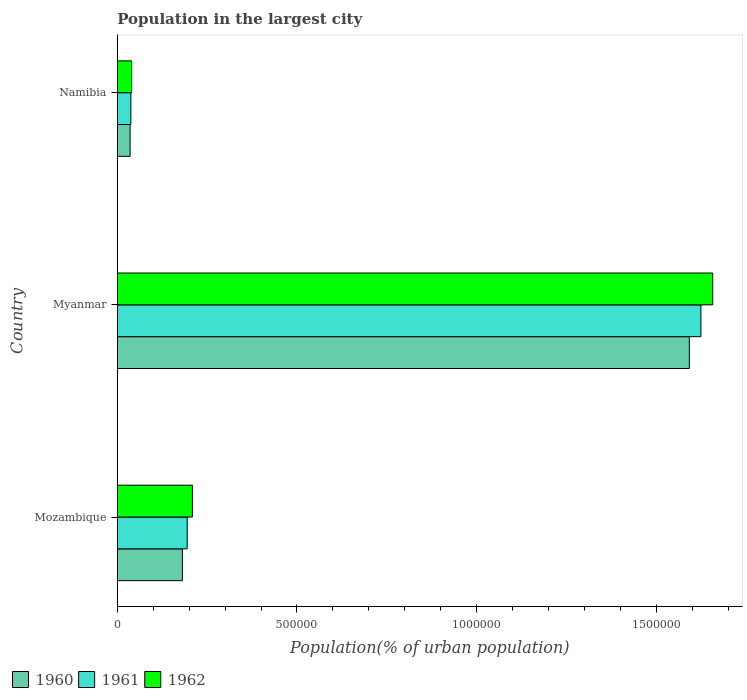Are the number of bars per tick equal to the number of legend labels?
Provide a succinct answer. Yes. Are the number of bars on each tick of the Y-axis equal?
Give a very brief answer. Yes. How many bars are there on the 1st tick from the top?
Offer a very short reply. 3. What is the label of the 1st group of bars from the top?
Your response must be concise. Namibia. In how many cases, is the number of bars for a given country not equal to the number of legend labels?
Make the answer very short. 0. What is the population in the largest city in 1960 in Mozambique?
Provide a short and direct response. 1.81e+05. Across all countries, what is the maximum population in the largest city in 1960?
Your answer should be compact. 1.59e+06. Across all countries, what is the minimum population in the largest city in 1962?
Your response must be concise. 3.99e+04. In which country was the population in the largest city in 1962 maximum?
Your response must be concise. Myanmar. In which country was the population in the largest city in 1962 minimum?
Your answer should be compact. Namibia. What is the total population in the largest city in 1960 in the graph?
Provide a short and direct response. 1.81e+06. What is the difference between the population in the largest city in 1961 in Mozambique and that in Namibia?
Offer a terse response. 1.57e+05. What is the difference between the population in the largest city in 1962 in Namibia and the population in the largest city in 1960 in Mozambique?
Offer a terse response. -1.41e+05. What is the average population in the largest city in 1961 per country?
Your response must be concise. 6.19e+05. What is the difference between the population in the largest city in 1960 and population in the largest city in 1961 in Myanmar?
Your response must be concise. -3.22e+04. What is the ratio of the population in the largest city in 1962 in Mozambique to that in Myanmar?
Provide a succinct answer. 0.13. What is the difference between the highest and the second highest population in the largest city in 1960?
Give a very brief answer. 1.41e+06. What is the difference between the highest and the lowest population in the largest city in 1960?
Provide a short and direct response. 1.56e+06. Is the sum of the population in the largest city in 1961 in Myanmar and Namibia greater than the maximum population in the largest city in 1962 across all countries?
Offer a terse response. Yes. What does the 1st bar from the top in Myanmar represents?
Provide a succinct answer. 1962. Is it the case that in every country, the sum of the population in the largest city in 1960 and population in the largest city in 1961 is greater than the population in the largest city in 1962?
Your answer should be very brief. Yes. Are all the bars in the graph horizontal?
Provide a succinct answer. Yes. What is the difference between two consecutive major ticks on the X-axis?
Make the answer very short. 5.00e+05. Does the graph contain any zero values?
Your answer should be very brief. No. Does the graph contain grids?
Provide a short and direct response. No. Where does the legend appear in the graph?
Offer a very short reply. Bottom left. What is the title of the graph?
Your response must be concise. Population in the largest city. Does "1995" appear as one of the legend labels in the graph?
Offer a very short reply. No. What is the label or title of the X-axis?
Ensure brevity in your answer.  Population(% of urban population). What is the label or title of the Y-axis?
Keep it short and to the point. Country. What is the Population(% of urban population) in 1960 in Mozambique?
Make the answer very short. 1.81e+05. What is the Population(% of urban population) in 1961 in Mozambique?
Your response must be concise. 1.95e+05. What is the Population(% of urban population) of 1962 in Mozambique?
Keep it short and to the point. 2.09e+05. What is the Population(% of urban population) of 1960 in Myanmar?
Offer a terse response. 1.59e+06. What is the Population(% of urban population) of 1961 in Myanmar?
Your answer should be very brief. 1.62e+06. What is the Population(% of urban population) in 1962 in Myanmar?
Offer a terse response. 1.66e+06. What is the Population(% of urban population) in 1960 in Namibia?
Your answer should be compact. 3.57e+04. What is the Population(% of urban population) of 1961 in Namibia?
Offer a very short reply. 3.77e+04. What is the Population(% of urban population) of 1962 in Namibia?
Make the answer very short. 3.99e+04. Across all countries, what is the maximum Population(% of urban population) in 1960?
Offer a very short reply. 1.59e+06. Across all countries, what is the maximum Population(% of urban population) in 1961?
Keep it short and to the point. 1.62e+06. Across all countries, what is the maximum Population(% of urban population) in 1962?
Your response must be concise. 1.66e+06. Across all countries, what is the minimum Population(% of urban population) of 1960?
Offer a very short reply. 3.57e+04. Across all countries, what is the minimum Population(% of urban population) in 1961?
Your answer should be compact. 3.77e+04. Across all countries, what is the minimum Population(% of urban population) in 1962?
Keep it short and to the point. 3.99e+04. What is the total Population(% of urban population) of 1960 in the graph?
Keep it short and to the point. 1.81e+06. What is the total Population(% of urban population) of 1961 in the graph?
Provide a succinct answer. 1.86e+06. What is the total Population(% of urban population) in 1962 in the graph?
Keep it short and to the point. 1.91e+06. What is the difference between the Population(% of urban population) in 1960 in Mozambique and that in Myanmar?
Provide a short and direct response. -1.41e+06. What is the difference between the Population(% of urban population) in 1961 in Mozambique and that in Myanmar?
Offer a terse response. -1.43e+06. What is the difference between the Population(% of urban population) in 1962 in Mozambique and that in Myanmar?
Make the answer very short. -1.45e+06. What is the difference between the Population(% of urban population) in 1960 in Mozambique and that in Namibia?
Make the answer very short. 1.46e+05. What is the difference between the Population(% of urban population) in 1961 in Mozambique and that in Namibia?
Provide a succinct answer. 1.57e+05. What is the difference between the Population(% of urban population) in 1962 in Mozambique and that in Namibia?
Keep it short and to the point. 1.69e+05. What is the difference between the Population(% of urban population) in 1960 in Myanmar and that in Namibia?
Your answer should be very brief. 1.56e+06. What is the difference between the Population(% of urban population) in 1961 in Myanmar and that in Namibia?
Give a very brief answer. 1.59e+06. What is the difference between the Population(% of urban population) of 1962 in Myanmar and that in Namibia?
Your response must be concise. 1.62e+06. What is the difference between the Population(% of urban population) of 1960 in Mozambique and the Population(% of urban population) of 1961 in Myanmar?
Provide a succinct answer. -1.44e+06. What is the difference between the Population(% of urban population) in 1960 in Mozambique and the Population(% of urban population) in 1962 in Myanmar?
Give a very brief answer. -1.48e+06. What is the difference between the Population(% of urban population) in 1961 in Mozambique and the Population(% of urban population) in 1962 in Myanmar?
Keep it short and to the point. -1.46e+06. What is the difference between the Population(% of urban population) in 1960 in Mozambique and the Population(% of urban population) in 1961 in Namibia?
Offer a terse response. 1.43e+05. What is the difference between the Population(% of urban population) in 1960 in Mozambique and the Population(% of urban population) in 1962 in Namibia?
Keep it short and to the point. 1.41e+05. What is the difference between the Population(% of urban population) of 1961 in Mozambique and the Population(% of urban population) of 1962 in Namibia?
Ensure brevity in your answer.  1.55e+05. What is the difference between the Population(% of urban population) in 1960 in Myanmar and the Population(% of urban population) in 1961 in Namibia?
Give a very brief answer. 1.55e+06. What is the difference between the Population(% of urban population) in 1960 in Myanmar and the Population(% of urban population) in 1962 in Namibia?
Your answer should be very brief. 1.55e+06. What is the difference between the Population(% of urban population) of 1961 in Myanmar and the Population(% of urban population) of 1962 in Namibia?
Your answer should be compact. 1.58e+06. What is the average Population(% of urban population) of 1960 per country?
Ensure brevity in your answer.  6.03e+05. What is the average Population(% of urban population) in 1961 per country?
Your response must be concise. 6.19e+05. What is the average Population(% of urban population) in 1962 per country?
Ensure brevity in your answer.  6.35e+05. What is the difference between the Population(% of urban population) in 1960 and Population(% of urban population) in 1961 in Mozambique?
Keep it short and to the point. -1.33e+04. What is the difference between the Population(% of urban population) in 1960 and Population(% of urban population) in 1962 in Mozambique?
Your answer should be very brief. -2.78e+04. What is the difference between the Population(% of urban population) of 1961 and Population(% of urban population) of 1962 in Mozambique?
Offer a very short reply. -1.45e+04. What is the difference between the Population(% of urban population) in 1960 and Population(% of urban population) in 1961 in Myanmar?
Keep it short and to the point. -3.22e+04. What is the difference between the Population(% of urban population) in 1960 and Population(% of urban population) in 1962 in Myanmar?
Provide a short and direct response. -6.52e+04. What is the difference between the Population(% of urban population) in 1961 and Population(% of urban population) in 1962 in Myanmar?
Offer a very short reply. -3.29e+04. What is the difference between the Population(% of urban population) of 1960 and Population(% of urban population) of 1961 in Namibia?
Offer a terse response. -2070. What is the difference between the Population(% of urban population) of 1960 and Population(% of urban population) of 1962 in Namibia?
Provide a short and direct response. -4228. What is the difference between the Population(% of urban population) in 1961 and Population(% of urban population) in 1962 in Namibia?
Your response must be concise. -2158. What is the ratio of the Population(% of urban population) in 1960 in Mozambique to that in Myanmar?
Give a very brief answer. 0.11. What is the ratio of the Population(% of urban population) of 1961 in Mozambique to that in Myanmar?
Your answer should be compact. 0.12. What is the ratio of the Population(% of urban population) of 1962 in Mozambique to that in Myanmar?
Offer a very short reply. 0.13. What is the ratio of the Population(% of urban population) of 1960 in Mozambique to that in Namibia?
Make the answer very short. 5.08. What is the ratio of the Population(% of urban population) of 1961 in Mozambique to that in Namibia?
Your answer should be very brief. 5.16. What is the ratio of the Population(% of urban population) in 1962 in Mozambique to that in Namibia?
Ensure brevity in your answer.  5.24. What is the ratio of the Population(% of urban population) in 1960 in Myanmar to that in Namibia?
Ensure brevity in your answer.  44.65. What is the ratio of the Population(% of urban population) in 1961 in Myanmar to that in Namibia?
Offer a very short reply. 43.06. What is the ratio of the Population(% of urban population) of 1962 in Myanmar to that in Namibia?
Provide a succinct answer. 41.55. What is the difference between the highest and the second highest Population(% of urban population) of 1960?
Make the answer very short. 1.41e+06. What is the difference between the highest and the second highest Population(% of urban population) of 1961?
Ensure brevity in your answer.  1.43e+06. What is the difference between the highest and the second highest Population(% of urban population) of 1962?
Offer a terse response. 1.45e+06. What is the difference between the highest and the lowest Population(% of urban population) of 1960?
Keep it short and to the point. 1.56e+06. What is the difference between the highest and the lowest Population(% of urban population) of 1961?
Offer a very short reply. 1.59e+06. What is the difference between the highest and the lowest Population(% of urban population) of 1962?
Provide a short and direct response. 1.62e+06. 